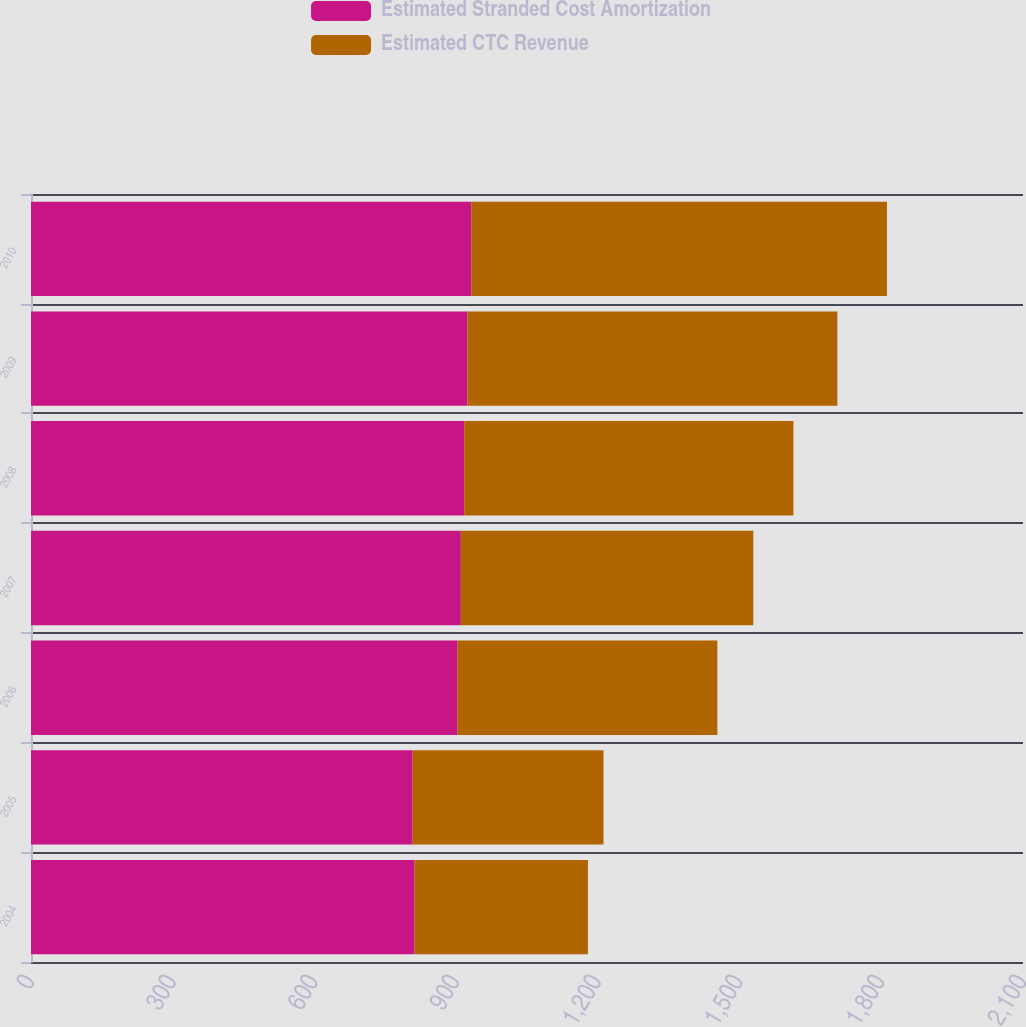Convert chart. <chart><loc_0><loc_0><loc_500><loc_500><stacked_bar_chart><ecel><fcel>2004<fcel>2005<fcel>2006<fcel>2007<fcel>2008<fcel>2009<fcel>2010<nl><fcel>Estimated Stranded Cost Amortization<fcel>812<fcel>808<fcel>903<fcel>910<fcel>917<fcel>924<fcel>932<nl><fcel>Estimated CTC Revenue<fcel>367<fcel>404<fcel>550<fcel>619<fcel>697<fcel>783<fcel>880<nl></chart> 